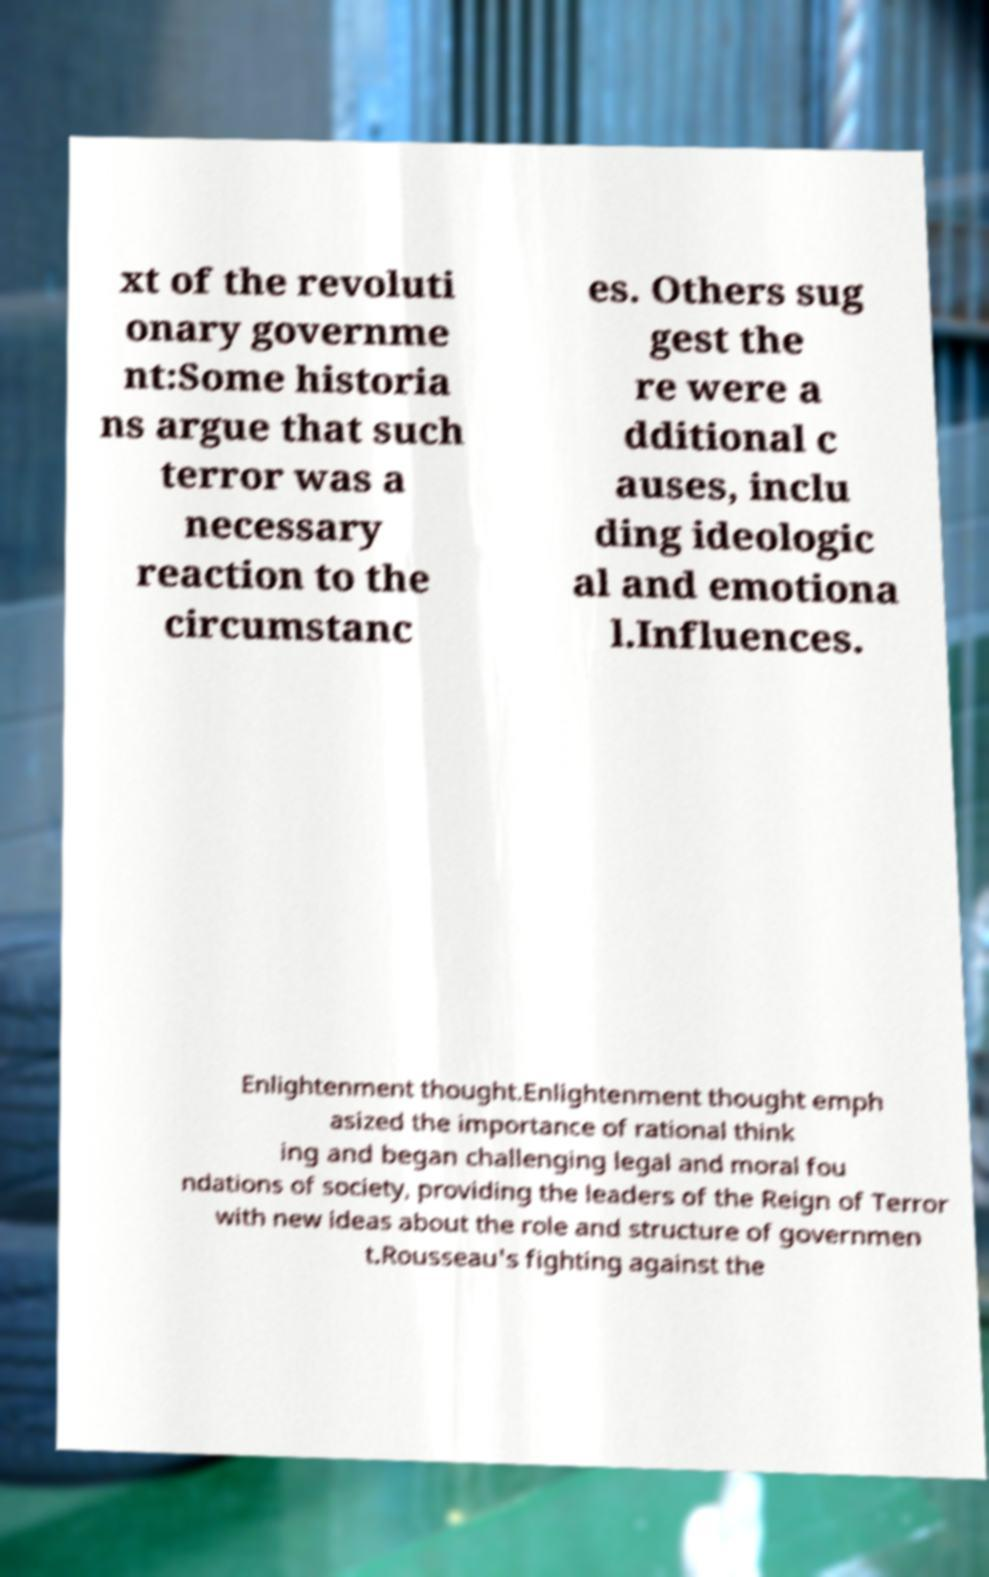What messages or text are displayed in this image? I need them in a readable, typed format. xt of the revoluti onary governme nt:Some historia ns argue that such terror was a necessary reaction to the circumstanc es. Others sug gest the re were a dditional c auses, inclu ding ideologic al and emotiona l.Influences. Enlightenment thought.Enlightenment thought emph asized the importance of rational think ing and began challenging legal and moral fou ndations of society, providing the leaders of the Reign of Terror with new ideas about the role and structure of governmen t.Rousseau's fighting against the 